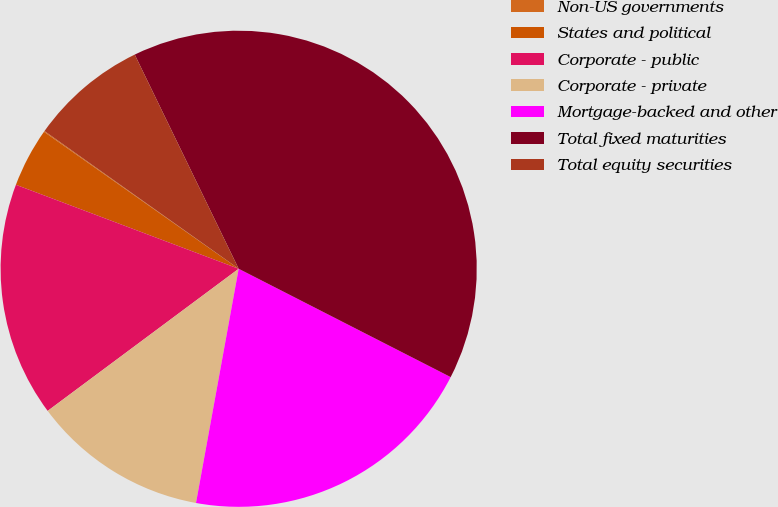<chart> <loc_0><loc_0><loc_500><loc_500><pie_chart><fcel>Non-US governments<fcel>States and political<fcel>Corporate - public<fcel>Corporate - private<fcel>Mortgage-backed and other<fcel>Total fixed maturities<fcel>Total equity securities<nl><fcel>0.06%<fcel>4.02%<fcel>15.92%<fcel>11.95%<fcel>20.35%<fcel>39.71%<fcel>7.99%<nl></chart> 